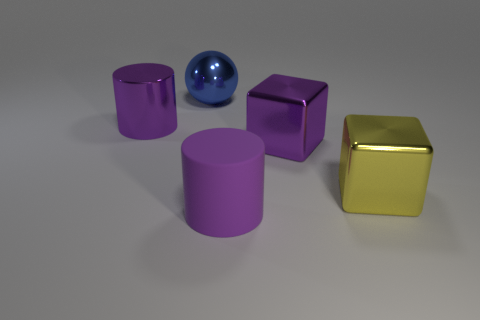What is the shape of the thing behind the shiny cylinder?
Offer a terse response. Sphere. How many other yellow shiny things are the same shape as the yellow thing?
Offer a terse response. 0. Is the number of large blue objects behind the yellow object the same as the number of purple cylinders behind the big sphere?
Provide a succinct answer. No. Are there any big purple things made of the same material as the big yellow block?
Offer a very short reply. Yes. How many gray things are large matte cylinders or cylinders?
Your answer should be very brief. 0. Is the number of large things that are behind the large yellow shiny object greater than the number of tiny red shiny cylinders?
Provide a succinct answer. Yes. Is there a large object of the same color as the large matte cylinder?
Provide a short and direct response. Yes. What is the size of the ball?
Provide a succinct answer. Large. Does the big matte thing have the same color as the shiny cylinder?
Your answer should be very brief. Yes. How many things are cylinders or shiny objects that are in front of the large blue ball?
Your answer should be very brief. 4. 